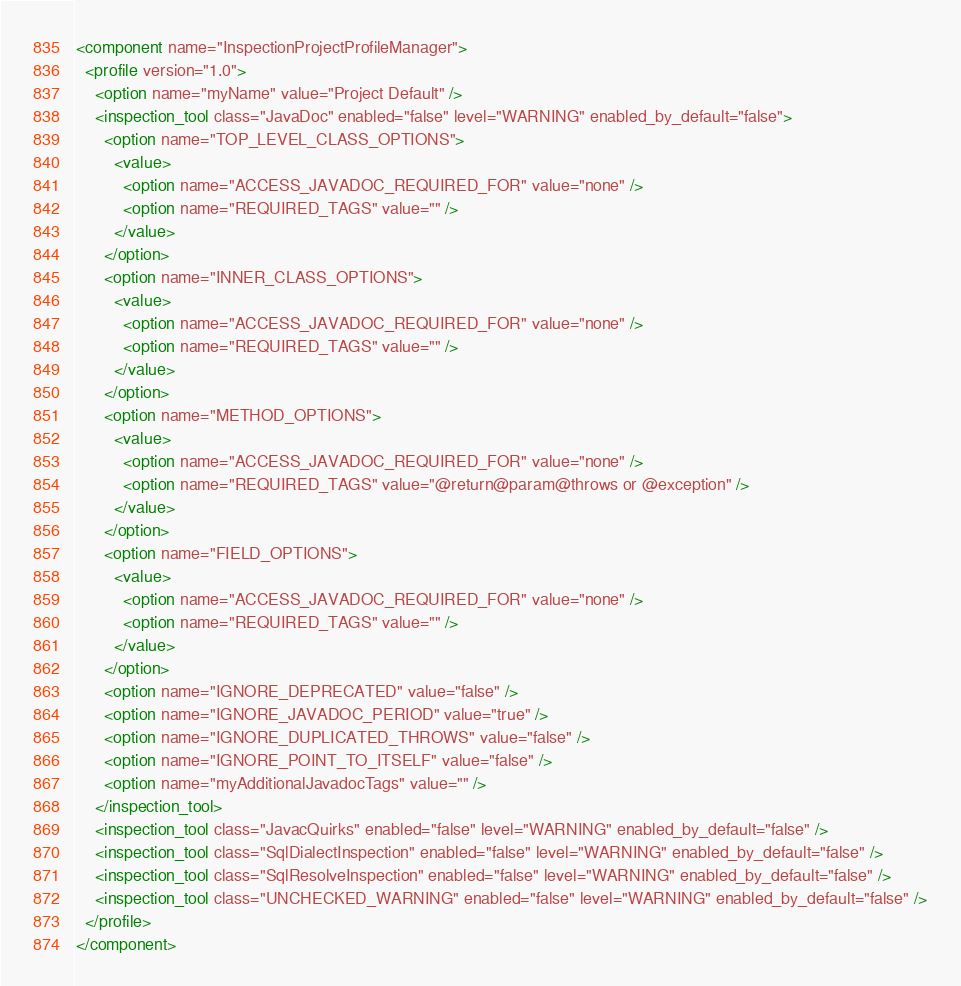<code> <loc_0><loc_0><loc_500><loc_500><_XML_><component name="InspectionProjectProfileManager">
  <profile version="1.0">
    <option name="myName" value="Project Default" />
    <inspection_tool class="JavaDoc" enabled="false" level="WARNING" enabled_by_default="false">
      <option name="TOP_LEVEL_CLASS_OPTIONS">
        <value>
          <option name="ACCESS_JAVADOC_REQUIRED_FOR" value="none" />
          <option name="REQUIRED_TAGS" value="" />
        </value>
      </option>
      <option name="INNER_CLASS_OPTIONS">
        <value>
          <option name="ACCESS_JAVADOC_REQUIRED_FOR" value="none" />
          <option name="REQUIRED_TAGS" value="" />
        </value>
      </option>
      <option name="METHOD_OPTIONS">
        <value>
          <option name="ACCESS_JAVADOC_REQUIRED_FOR" value="none" />
          <option name="REQUIRED_TAGS" value="@return@param@throws or @exception" />
        </value>
      </option>
      <option name="FIELD_OPTIONS">
        <value>
          <option name="ACCESS_JAVADOC_REQUIRED_FOR" value="none" />
          <option name="REQUIRED_TAGS" value="" />
        </value>
      </option>
      <option name="IGNORE_DEPRECATED" value="false" />
      <option name="IGNORE_JAVADOC_PERIOD" value="true" />
      <option name="IGNORE_DUPLICATED_THROWS" value="false" />
      <option name="IGNORE_POINT_TO_ITSELF" value="false" />
      <option name="myAdditionalJavadocTags" value="" />
    </inspection_tool>
    <inspection_tool class="JavacQuirks" enabled="false" level="WARNING" enabled_by_default="false" />
    <inspection_tool class="SqlDialectInspection" enabled="false" level="WARNING" enabled_by_default="false" />
    <inspection_tool class="SqlResolveInspection" enabled="false" level="WARNING" enabled_by_default="false" />
    <inspection_tool class="UNCHECKED_WARNING" enabled="false" level="WARNING" enabled_by_default="false" />
  </profile>
</component></code> 